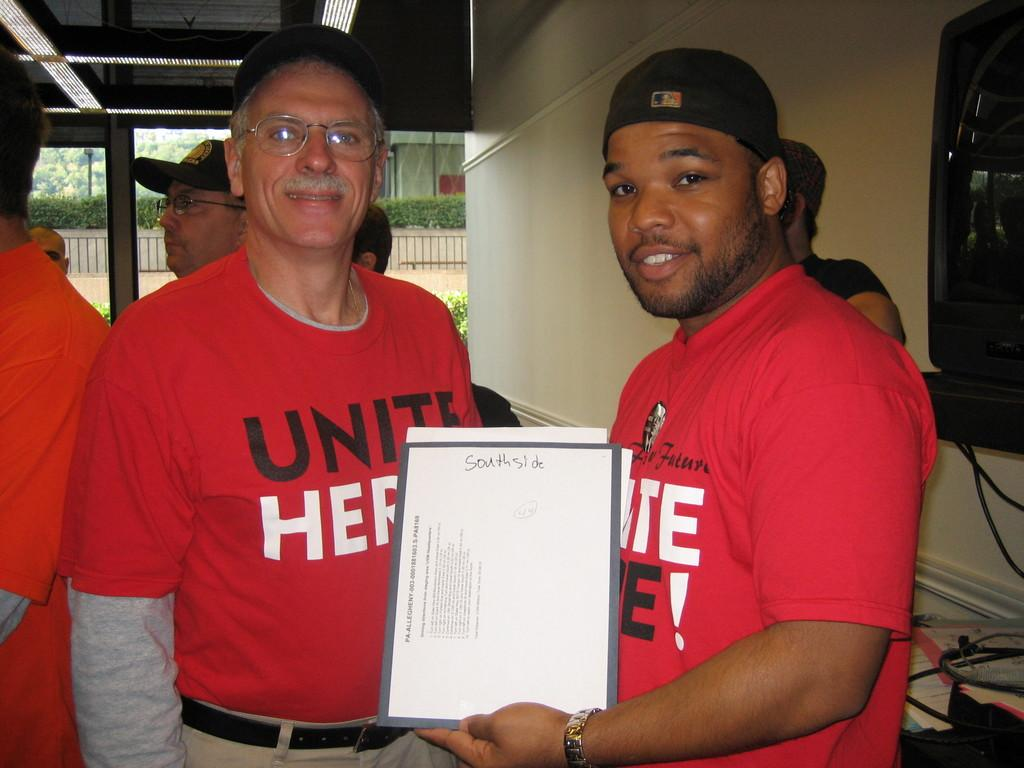<image>
Present a compact description of the photo's key features. Two men in Unite t-shirts hold a paper for Southside. 